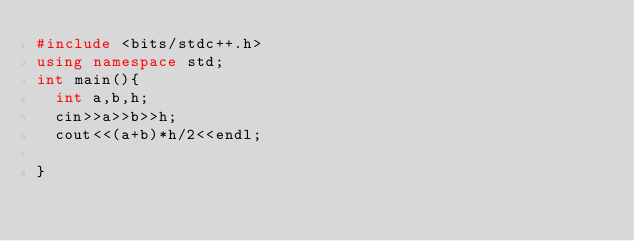Convert code to text. <code><loc_0><loc_0><loc_500><loc_500><_C++_>#include <bits/stdc++.h>
using namespace std;
int main(){
  int a,b,h;
  cin>>a>>b>>h;
  cout<<(a+b)*h/2<<endl;
  
}</code> 